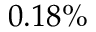Convert formula to latex. <formula><loc_0><loc_0><loc_500><loc_500>0 . 1 8 \%</formula> 